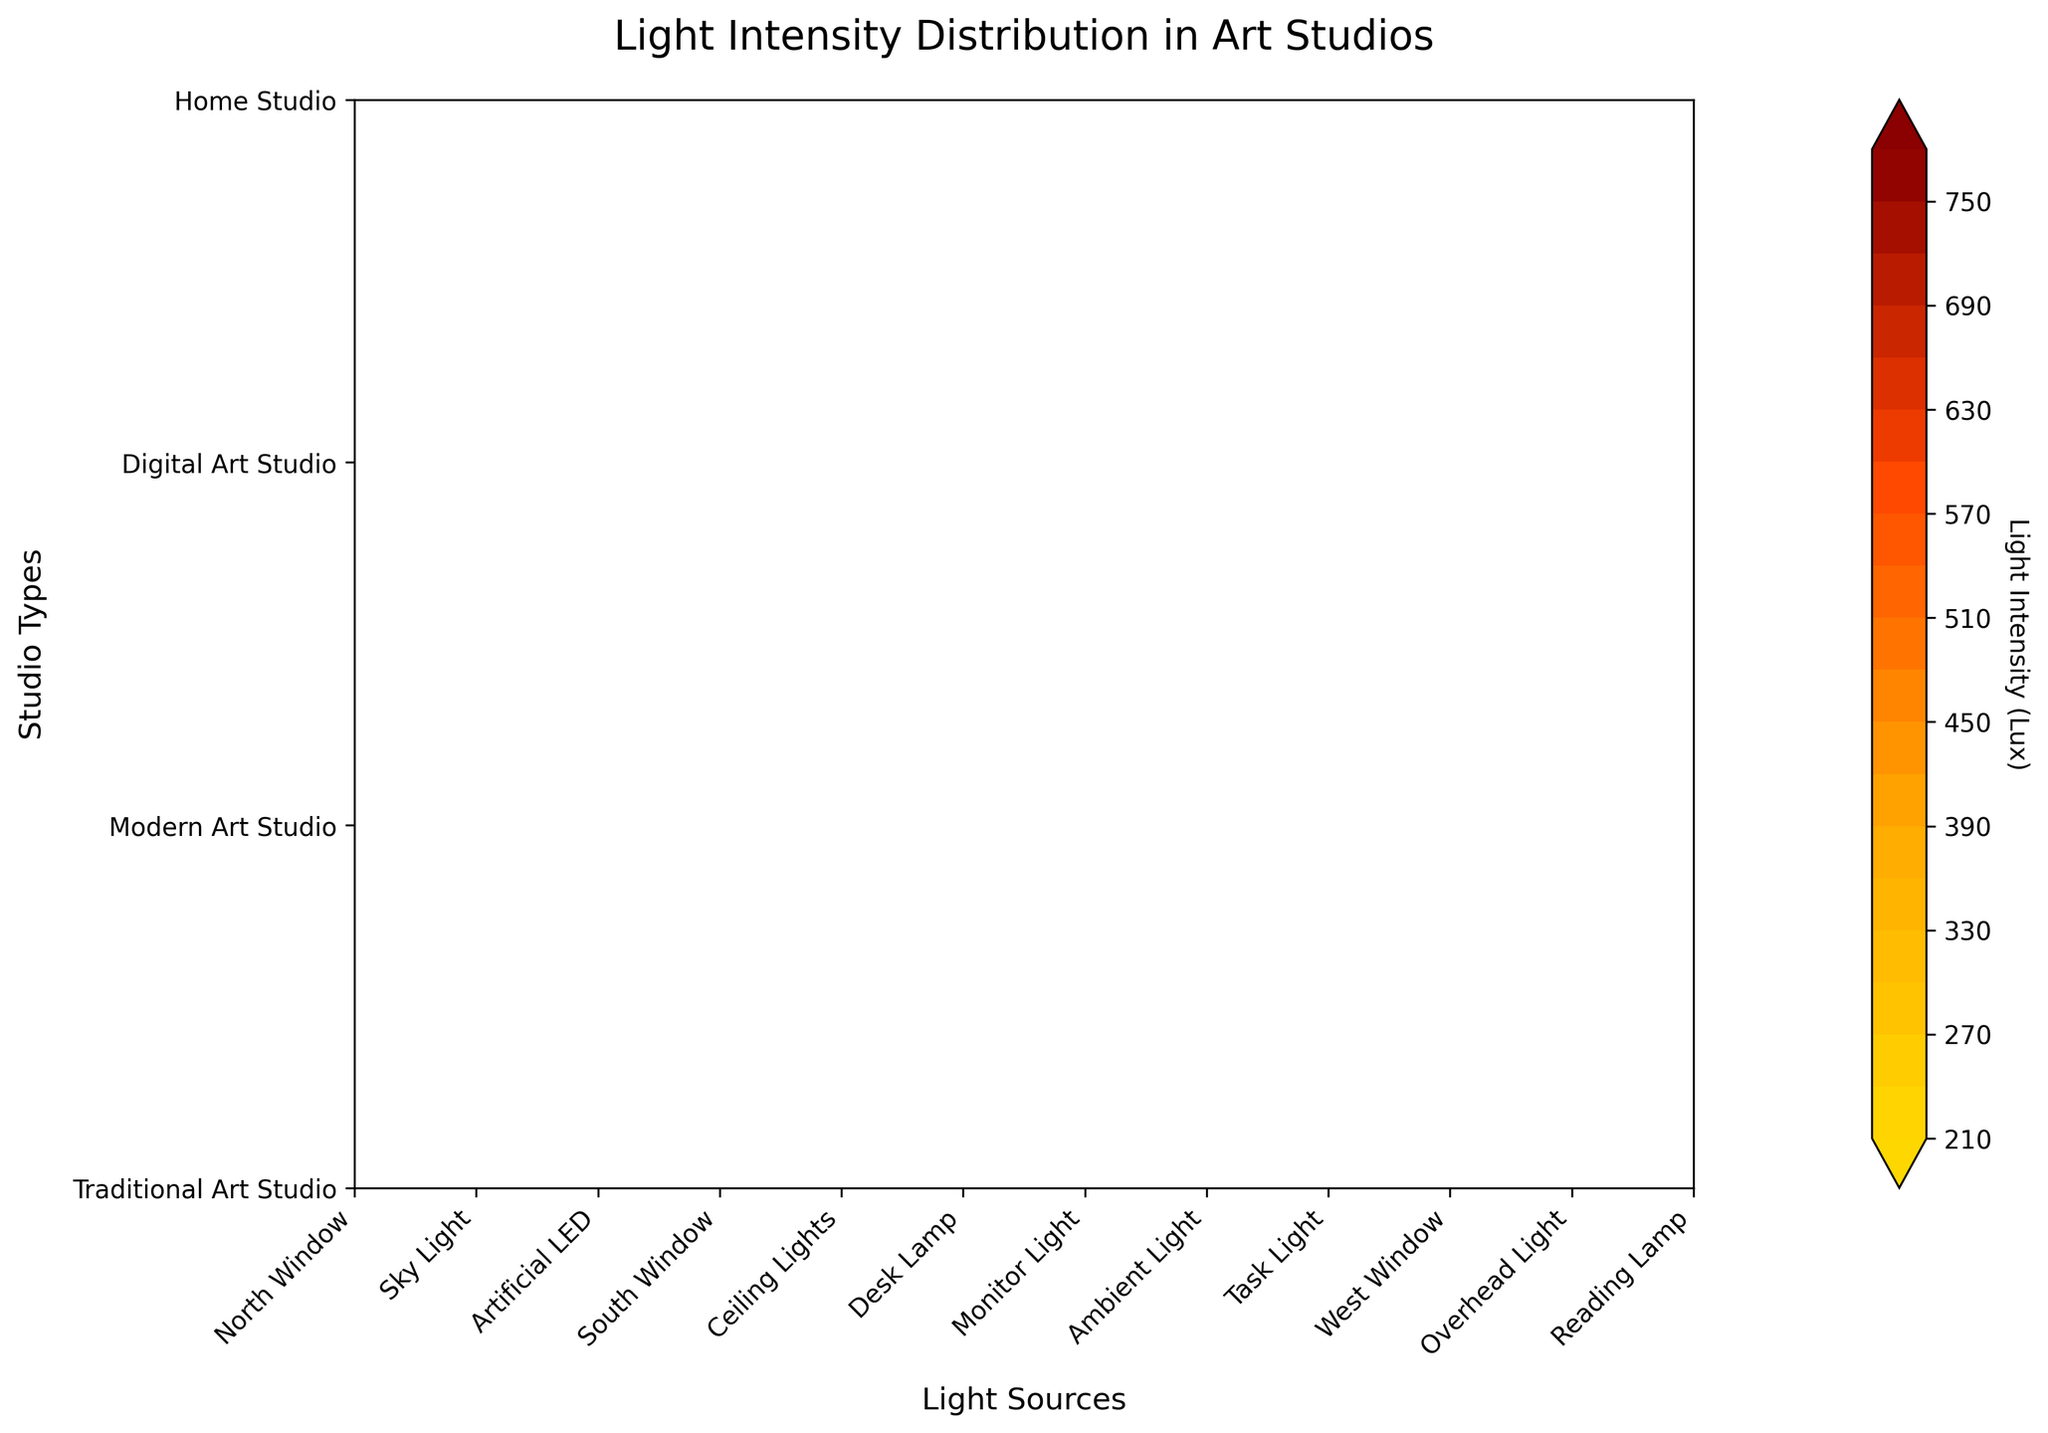How many different studios are represented in the figure? Look at the y-axis labels, which indicate different types of studios. Count the unique studio names listed on the y-axis: "Traditional Art Studio", "Modern Art Studio", "Digital Art Studio", and "Home Studio".
Answer: 4 What is the highest light intensity recorded in the Modern Art Studio? Identify the Modern Art Studio row and look for the highest contour label within this row. The highest light intensity occurs at the "South Window", which is labeled 800 Lux.
Answer: 800 Lux Which studio has the lowest recorded light intensity and what is it? Examine the contour labels across all rows and identify the lowest value. This value is 200 Lux, found in the "Digital Art Studio" at the "Ambient Light".
Answer: Digital Art Studio, 200 Lux Compare the light intensity of the "South Window" in Modern Art Studio and the "North Window" in Traditional Art Studio. Which one is higher and by how much? Find the value of the "South Window" in Modern Art Studio (800 Lux) and the value of the "North Window" in Traditional Art Studio (500 Lux). Subtract the latter from the former to find the difference: 800 Lux - 500 Lux = 300 Lux.
Answer: South Window (Modern Art Studio) by 300 Lux What is the average light intensity for the "Home Studio"? Retrieve and sum the Lux values for all light sources in the "Home Studio" row: 650 (West Window) + 550 (Overhead Light) + 250 (Reading Lamp) = 1450. There are 3 data points, so divide the sum by 3: 1450 / 3 ≈ 483.33 Lux.
Answer: 483.33 Lux For which studio does the "Desk Lamp" light source provide the lowest intensity? Locate the "Desk Lamp" light sources in different studios. The corresponding Lux value is lowest in the Modern Art Studio with 350 Lux.
Answer: Modern Art Studio Which light source has the highest light intensity in the Digital Art Studio? Identify the light source in the Digital Art Studio row with the highest contour label. The "Task Light" has the highest value at 700 Lux.
Answer: Task Light What is the difference in light intensity between the "Sky Light" in Traditional Art Studio and the "Task Light" in Digital Art Studio? Find the contour labels for the "Sky Light" in Traditional Art Studio (750 Lux) and the "Task Light" in Digital Art Studio (700 Lux). Subtract the latter from the former: 750 Lux - 700 Lux = 50 Lux.
Answer: 50 Lux In which studio does the "Artificial LED" light source appear and what is its light intensity? Locate the "Artificial LED" light source label in the contour plot. It appears in the Traditional Art Studio with a light intensity of 300 Lux.
Answer: Traditional Art Studio, 300 Lux 